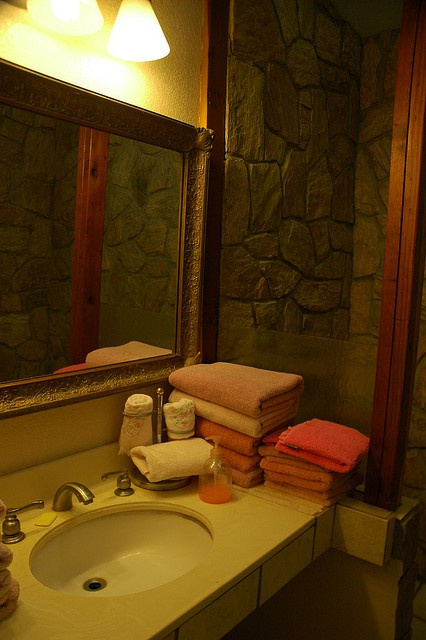Describe the objects in this image and their specific colors. I can see a sink in black, olive, and maroon tones in this image. 